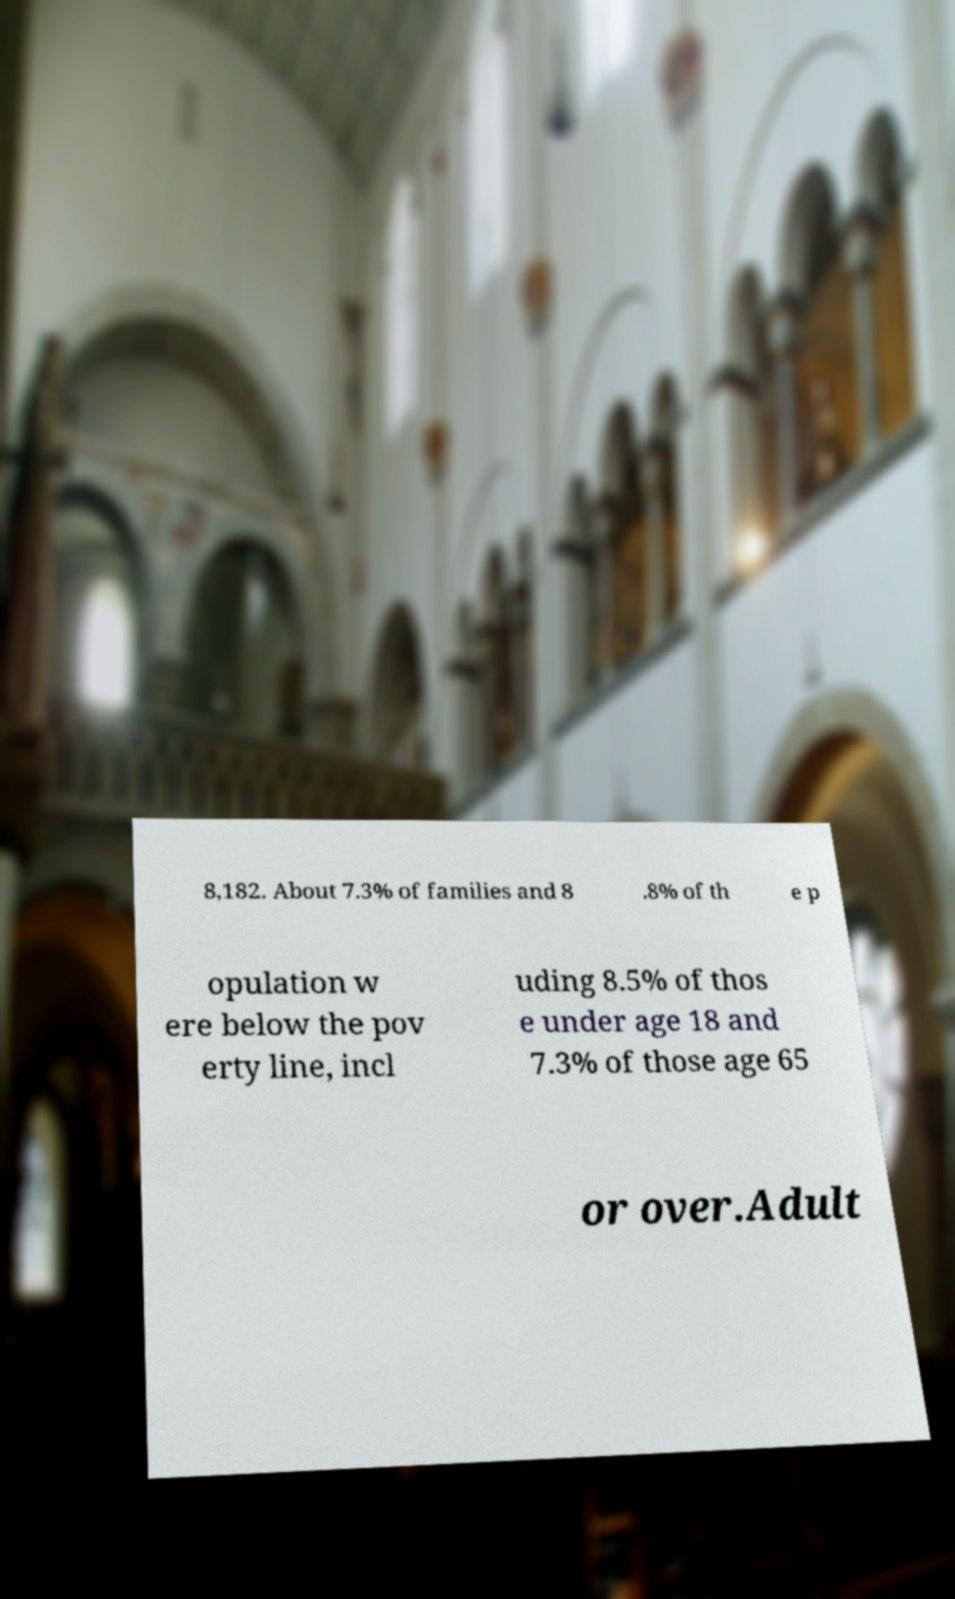For documentation purposes, I need the text within this image transcribed. Could you provide that? 8,182. About 7.3% of families and 8 .8% of th e p opulation w ere below the pov erty line, incl uding 8.5% of thos e under age 18 and 7.3% of those age 65 or over.Adult 